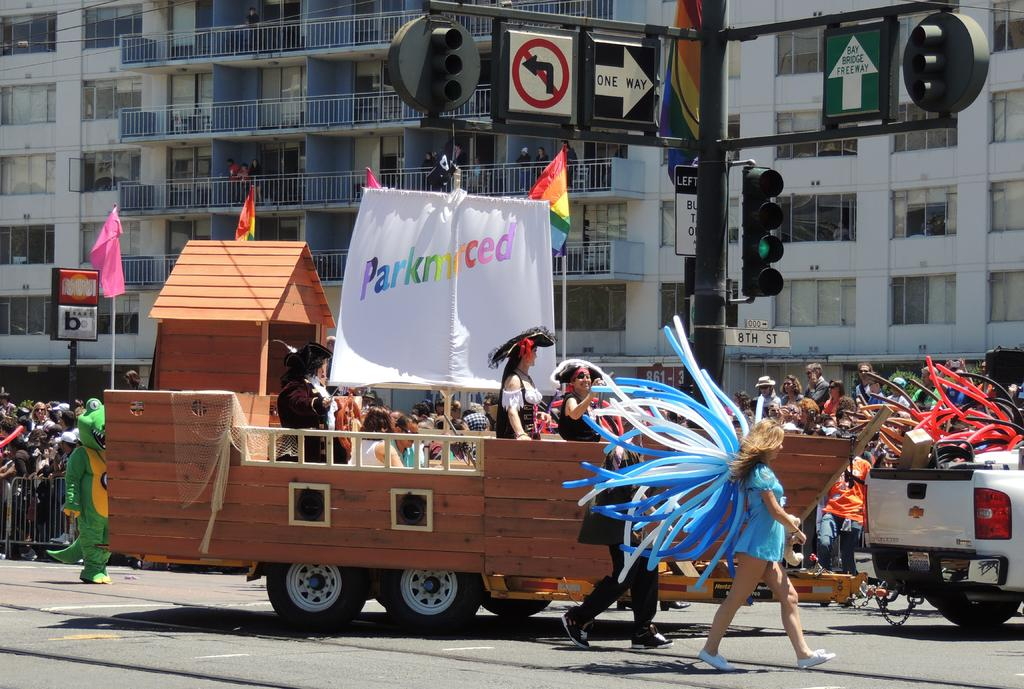What are the persons in the image doing? The persons in the image are standing on a vehicle. How many persons are standing beside the vehicle? There are two persons standing beside the vehicle. Who else can be seen in the image besides the persons on and beside the vehicle? There are audience members in the image. What can be seen in the background of the image? There are buildings in the background of the image. What type of worm can be seen crawling on the vehicle in the image? There is no worm present in the image; it only features persons standing on and beside the vehicle, audience members, and buildings in the background. 